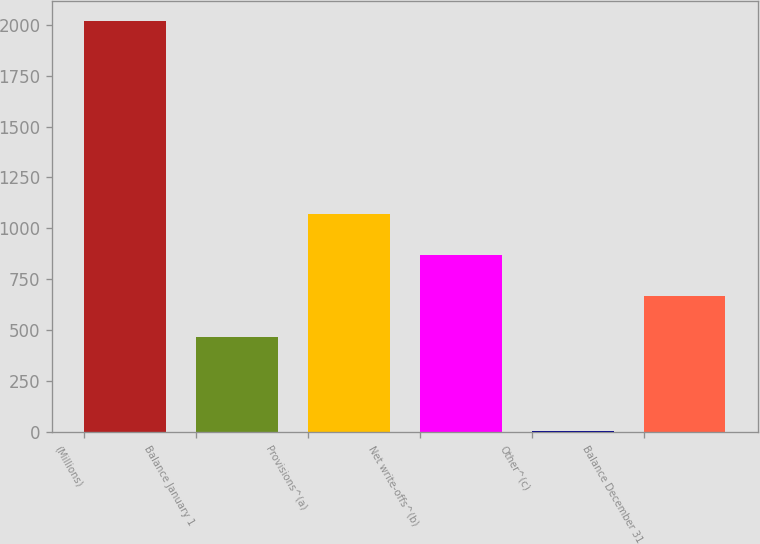Convert chart to OTSL. <chart><loc_0><loc_0><loc_500><loc_500><bar_chart><fcel>(Millions)<fcel>Balance January 1<fcel>Provisions^(a)<fcel>Net write-offs^(b)<fcel>Other^(c)<fcel>Balance December 31<nl><fcel>2017<fcel>467<fcel>1070.6<fcel>869.4<fcel>5<fcel>668.2<nl></chart> 